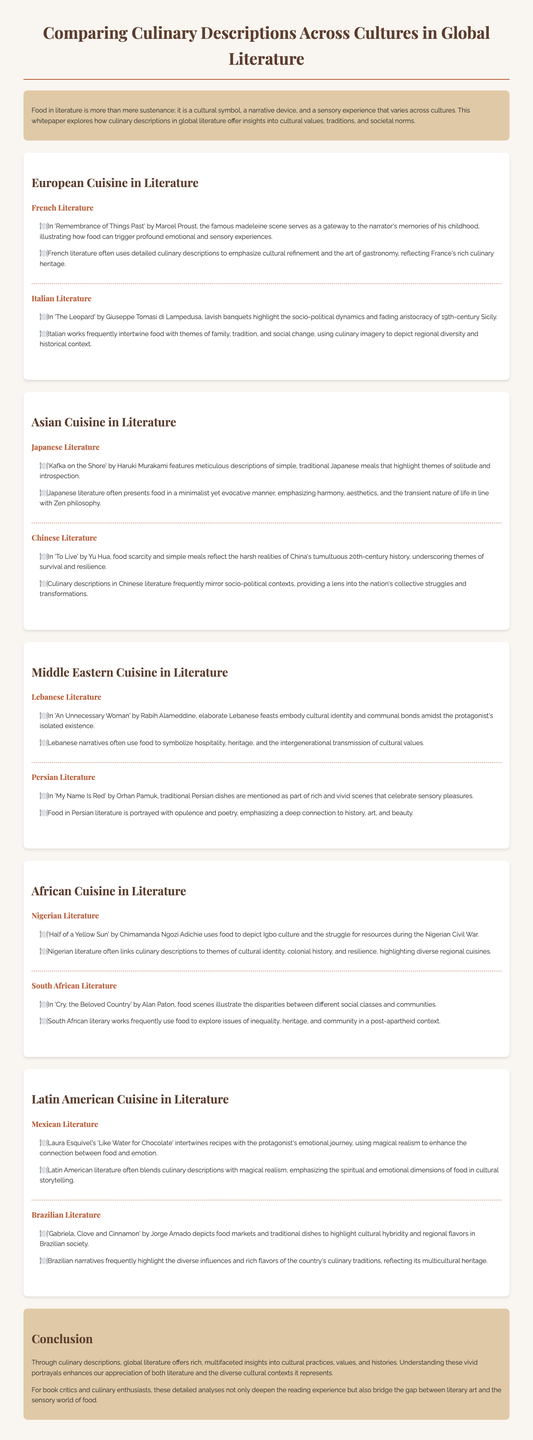What is the title of the whitepaper? The title is prominently displayed at the top of the document, identifying the topic of discussion.
Answer: Comparing Culinary Descriptions Across Cultures in Global Literature Who is the author of 'Remembrance of Things Past'? The author is mentioned in the section about French literature, indicating their contribution to this literary work.
Answer: Marcel Proust What theme is highlighted in 'To Live' by Yu Hua? The description outlines the focus of the culinary imagery presented in this literature, reflecting on historical events.
Answer: Survival and resilience Which Asian literary work emphasizes minimalist culinary descriptions? This work is noted in the Japanese cuisine section, illustrating the cultural approach to food in literature.
Answer: Kafka on the Shore What does Lebanese literature symbolize through food? This symbolism is discussed in relation to cultural identity and communal aspects of the narratives examined.
Answer: Hospitality, heritage How are culinary descriptions used in Mexican literature? The whitepaper details how food is intertwined with emotional journeys within this literary genre.
Answer: Emotional journey Which cuisine is explored in the comparison of 'Gabriela, Clove and Cinnamon'? This title relates to the exploration of Brazilian society and its culinary traditions within the context of the whitepaper.
Answer: Brazilian What cultural aspect is affirmed by Nigerian literature's culinary scenes? The analysis points to the deeper connections between food and historical struggles presented in the narratives.
Answer: Cultural identity 